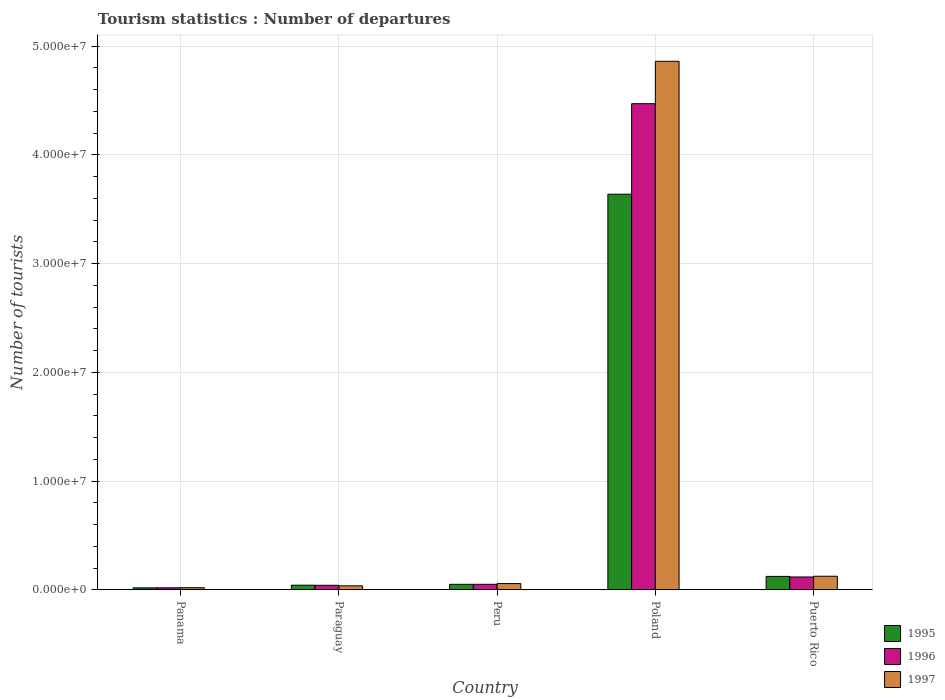How many different coloured bars are there?
Provide a succinct answer. 3. How many groups of bars are there?
Offer a very short reply. 5. How many bars are there on the 2nd tick from the right?
Give a very brief answer. 3. What is the label of the 5th group of bars from the left?
Provide a succinct answer. Puerto Rico. In how many cases, is the number of bars for a given country not equal to the number of legend labels?
Keep it short and to the point. 0. What is the number of tourist departures in 1995 in Panama?
Give a very brief answer. 1.85e+05. Across all countries, what is the maximum number of tourist departures in 1997?
Give a very brief answer. 4.86e+07. Across all countries, what is the minimum number of tourist departures in 1997?
Offer a very short reply. 1.94e+05. In which country was the number of tourist departures in 1997 minimum?
Provide a short and direct response. Panama. What is the total number of tourist departures in 1996 in the graph?
Provide a short and direct response. 4.70e+07. What is the difference between the number of tourist departures in 1995 in Panama and that in Poland?
Your answer should be very brief. -3.62e+07. What is the difference between the number of tourist departures in 1995 in Peru and the number of tourist departures in 1997 in Paraguay?
Your answer should be very brief. 1.39e+05. What is the average number of tourist departures in 1995 per country?
Your answer should be very brief. 7.75e+06. What is the difference between the number of tourist departures of/in 1995 and number of tourist departures of/in 1996 in Panama?
Your answer should be very brief. -3000. In how many countries, is the number of tourist departures in 1997 greater than 46000000?
Make the answer very short. 1. What is the ratio of the number of tourist departures in 1997 in Peru to that in Poland?
Offer a terse response. 0.01. What is the difference between the highest and the second highest number of tourist departures in 1997?
Provide a succinct answer. 4.80e+07. What is the difference between the highest and the lowest number of tourist departures in 1995?
Give a very brief answer. 3.62e+07. Is the sum of the number of tourist departures in 1996 in Panama and Puerto Rico greater than the maximum number of tourist departures in 1997 across all countries?
Give a very brief answer. No. What does the 1st bar from the right in Puerto Rico represents?
Provide a succinct answer. 1997. How many bars are there?
Offer a very short reply. 15. Are all the bars in the graph horizontal?
Provide a succinct answer. No. What is the difference between two consecutive major ticks on the Y-axis?
Provide a succinct answer. 1.00e+07. Are the values on the major ticks of Y-axis written in scientific E-notation?
Your answer should be very brief. Yes. How many legend labels are there?
Your answer should be compact. 3. How are the legend labels stacked?
Your answer should be compact. Vertical. What is the title of the graph?
Provide a succinct answer. Tourism statistics : Number of departures. Does "2013" appear as one of the legend labels in the graph?
Your response must be concise. No. What is the label or title of the X-axis?
Ensure brevity in your answer.  Country. What is the label or title of the Y-axis?
Offer a very short reply. Number of tourists. What is the Number of tourists in 1995 in Panama?
Your response must be concise. 1.85e+05. What is the Number of tourists of 1996 in Panama?
Ensure brevity in your answer.  1.88e+05. What is the Number of tourists in 1997 in Panama?
Ensure brevity in your answer.  1.94e+05. What is the Number of tourists in 1995 in Paraguay?
Your response must be concise. 4.27e+05. What is the Number of tourists of 1996 in Paraguay?
Your answer should be very brief. 4.18e+05. What is the Number of tourists of 1997 in Paraguay?
Make the answer very short. 3.69e+05. What is the Number of tourists of 1995 in Peru?
Your answer should be very brief. 5.08e+05. What is the Number of tourists of 1996 in Peru?
Provide a short and direct response. 5.10e+05. What is the Number of tourists of 1997 in Peru?
Make the answer very short. 5.77e+05. What is the Number of tourists of 1995 in Poland?
Provide a succinct answer. 3.64e+07. What is the Number of tourists of 1996 in Poland?
Provide a succinct answer. 4.47e+07. What is the Number of tourists in 1997 in Poland?
Your response must be concise. 4.86e+07. What is the Number of tourists of 1995 in Puerto Rico?
Your response must be concise. 1.24e+06. What is the Number of tourists in 1996 in Puerto Rico?
Give a very brief answer. 1.18e+06. What is the Number of tourists of 1997 in Puerto Rico?
Ensure brevity in your answer.  1.25e+06. Across all countries, what is the maximum Number of tourists in 1995?
Your answer should be very brief. 3.64e+07. Across all countries, what is the maximum Number of tourists of 1996?
Your response must be concise. 4.47e+07. Across all countries, what is the maximum Number of tourists in 1997?
Make the answer very short. 4.86e+07. Across all countries, what is the minimum Number of tourists in 1995?
Your answer should be compact. 1.85e+05. Across all countries, what is the minimum Number of tourists in 1996?
Make the answer very short. 1.88e+05. Across all countries, what is the minimum Number of tourists in 1997?
Give a very brief answer. 1.94e+05. What is the total Number of tourists in 1995 in the graph?
Your answer should be very brief. 3.87e+07. What is the total Number of tourists of 1996 in the graph?
Make the answer very short. 4.70e+07. What is the total Number of tourists in 1997 in the graph?
Your answer should be compact. 5.10e+07. What is the difference between the Number of tourists in 1995 in Panama and that in Paraguay?
Ensure brevity in your answer.  -2.42e+05. What is the difference between the Number of tourists of 1996 in Panama and that in Paraguay?
Your response must be concise. -2.30e+05. What is the difference between the Number of tourists in 1997 in Panama and that in Paraguay?
Keep it short and to the point. -1.75e+05. What is the difference between the Number of tourists of 1995 in Panama and that in Peru?
Provide a succinct answer. -3.23e+05. What is the difference between the Number of tourists in 1996 in Panama and that in Peru?
Offer a very short reply. -3.22e+05. What is the difference between the Number of tourists of 1997 in Panama and that in Peru?
Ensure brevity in your answer.  -3.83e+05. What is the difference between the Number of tourists of 1995 in Panama and that in Poland?
Your response must be concise. -3.62e+07. What is the difference between the Number of tourists of 1996 in Panama and that in Poland?
Give a very brief answer. -4.45e+07. What is the difference between the Number of tourists of 1997 in Panama and that in Poland?
Ensure brevity in your answer.  -4.84e+07. What is the difference between the Number of tourists in 1995 in Panama and that in Puerto Rico?
Offer a very short reply. -1.05e+06. What is the difference between the Number of tourists in 1996 in Panama and that in Puerto Rico?
Your answer should be compact. -9.96e+05. What is the difference between the Number of tourists in 1997 in Panama and that in Puerto Rico?
Ensure brevity in your answer.  -1.06e+06. What is the difference between the Number of tourists in 1995 in Paraguay and that in Peru?
Offer a very short reply. -8.10e+04. What is the difference between the Number of tourists of 1996 in Paraguay and that in Peru?
Your answer should be compact. -9.20e+04. What is the difference between the Number of tourists of 1997 in Paraguay and that in Peru?
Make the answer very short. -2.08e+05. What is the difference between the Number of tourists in 1995 in Paraguay and that in Poland?
Ensure brevity in your answer.  -3.60e+07. What is the difference between the Number of tourists in 1996 in Paraguay and that in Poland?
Your answer should be very brief. -4.43e+07. What is the difference between the Number of tourists of 1997 in Paraguay and that in Poland?
Keep it short and to the point. -4.82e+07. What is the difference between the Number of tourists in 1995 in Paraguay and that in Puerto Rico?
Keep it short and to the point. -8.10e+05. What is the difference between the Number of tourists of 1996 in Paraguay and that in Puerto Rico?
Your answer should be very brief. -7.66e+05. What is the difference between the Number of tourists in 1997 in Paraguay and that in Puerto Rico?
Provide a succinct answer. -8.82e+05. What is the difference between the Number of tourists in 1995 in Peru and that in Poland?
Your answer should be compact. -3.59e+07. What is the difference between the Number of tourists in 1996 in Peru and that in Poland?
Give a very brief answer. -4.42e+07. What is the difference between the Number of tourists of 1997 in Peru and that in Poland?
Your answer should be compact. -4.80e+07. What is the difference between the Number of tourists of 1995 in Peru and that in Puerto Rico?
Provide a short and direct response. -7.29e+05. What is the difference between the Number of tourists of 1996 in Peru and that in Puerto Rico?
Your answer should be very brief. -6.74e+05. What is the difference between the Number of tourists of 1997 in Peru and that in Puerto Rico?
Offer a very short reply. -6.74e+05. What is the difference between the Number of tourists in 1995 in Poland and that in Puerto Rico?
Your answer should be very brief. 3.52e+07. What is the difference between the Number of tourists in 1996 in Poland and that in Puerto Rico?
Your answer should be very brief. 4.35e+07. What is the difference between the Number of tourists of 1997 in Poland and that in Puerto Rico?
Make the answer very short. 4.74e+07. What is the difference between the Number of tourists of 1995 in Panama and the Number of tourists of 1996 in Paraguay?
Offer a terse response. -2.33e+05. What is the difference between the Number of tourists of 1995 in Panama and the Number of tourists of 1997 in Paraguay?
Provide a short and direct response. -1.84e+05. What is the difference between the Number of tourists in 1996 in Panama and the Number of tourists in 1997 in Paraguay?
Your response must be concise. -1.81e+05. What is the difference between the Number of tourists of 1995 in Panama and the Number of tourists of 1996 in Peru?
Give a very brief answer. -3.25e+05. What is the difference between the Number of tourists in 1995 in Panama and the Number of tourists in 1997 in Peru?
Provide a short and direct response. -3.92e+05. What is the difference between the Number of tourists of 1996 in Panama and the Number of tourists of 1997 in Peru?
Provide a succinct answer. -3.89e+05. What is the difference between the Number of tourists of 1995 in Panama and the Number of tourists of 1996 in Poland?
Give a very brief answer. -4.45e+07. What is the difference between the Number of tourists in 1995 in Panama and the Number of tourists in 1997 in Poland?
Provide a succinct answer. -4.84e+07. What is the difference between the Number of tourists in 1996 in Panama and the Number of tourists in 1997 in Poland?
Offer a terse response. -4.84e+07. What is the difference between the Number of tourists of 1995 in Panama and the Number of tourists of 1996 in Puerto Rico?
Provide a short and direct response. -9.99e+05. What is the difference between the Number of tourists in 1995 in Panama and the Number of tourists in 1997 in Puerto Rico?
Provide a succinct answer. -1.07e+06. What is the difference between the Number of tourists of 1996 in Panama and the Number of tourists of 1997 in Puerto Rico?
Your response must be concise. -1.06e+06. What is the difference between the Number of tourists in 1995 in Paraguay and the Number of tourists in 1996 in Peru?
Your answer should be compact. -8.30e+04. What is the difference between the Number of tourists of 1996 in Paraguay and the Number of tourists of 1997 in Peru?
Give a very brief answer. -1.59e+05. What is the difference between the Number of tourists in 1995 in Paraguay and the Number of tourists in 1996 in Poland?
Your response must be concise. -4.43e+07. What is the difference between the Number of tourists in 1995 in Paraguay and the Number of tourists in 1997 in Poland?
Make the answer very short. -4.82e+07. What is the difference between the Number of tourists of 1996 in Paraguay and the Number of tourists of 1997 in Poland?
Offer a terse response. -4.82e+07. What is the difference between the Number of tourists of 1995 in Paraguay and the Number of tourists of 1996 in Puerto Rico?
Your response must be concise. -7.57e+05. What is the difference between the Number of tourists of 1995 in Paraguay and the Number of tourists of 1997 in Puerto Rico?
Ensure brevity in your answer.  -8.24e+05. What is the difference between the Number of tourists in 1996 in Paraguay and the Number of tourists in 1997 in Puerto Rico?
Keep it short and to the point. -8.33e+05. What is the difference between the Number of tourists in 1995 in Peru and the Number of tourists in 1996 in Poland?
Keep it short and to the point. -4.42e+07. What is the difference between the Number of tourists in 1995 in Peru and the Number of tourists in 1997 in Poland?
Give a very brief answer. -4.81e+07. What is the difference between the Number of tourists of 1996 in Peru and the Number of tourists of 1997 in Poland?
Offer a very short reply. -4.81e+07. What is the difference between the Number of tourists in 1995 in Peru and the Number of tourists in 1996 in Puerto Rico?
Your answer should be compact. -6.76e+05. What is the difference between the Number of tourists in 1995 in Peru and the Number of tourists in 1997 in Puerto Rico?
Your response must be concise. -7.43e+05. What is the difference between the Number of tourists in 1996 in Peru and the Number of tourists in 1997 in Puerto Rico?
Your answer should be very brief. -7.41e+05. What is the difference between the Number of tourists of 1995 in Poland and the Number of tourists of 1996 in Puerto Rico?
Your answer should be very brief. 3.52e+07. What is the difference between the Number of tourists in 1995 in Poland and the Number of tourists in 1997 in Puerto Rico?
Keep it short and to the point. 3.51e+07. What is the difference between the Number of tourists of 1996 in Poland and the Number of tourists of 1997 in Puerto Rico?
Offer a very short reply. 4.35e+07. What is the average Number of tourists in 1995 per country?
Offer a very short reply. 7.75e+06. What is the average Number of tourists of 1996 per country?
Give a very brief answer. 9.40e+06. What is the average Number of tourists in 1997 per country?
Provide a succinct answer. 1.02e+07. What is the difference between the Number of tourists in 1995 and Number of tourists in 1996 in Panama?
Ensure brevity in your answer.  -3000. What is the difference between the Number of tourists of 1995 and Number of tourists of 1997 in Panama?
Your answer should be very brief. -9000. What is the difference between the Number of tourists of 1996 and Number of tourists of 1997 in Panama?
Offer a terse response. -6000. What is the difference between the Number of tourists of 1995 and Number of tourists of 1996 in Paraguay?
Keep it short and to the point. 9000. What is the difference between the Number of tourists of 1995 and Number of tourists of 1997 in Paraguay?
Your answer should be very brief. 5.80e+04. What is the difference between the Number of tourists of 1996 and Number of tourists of 1997 in Paraguay?
Provide a short and direct response. 4.90e+04. What is the difference between the Number of tourists of 1995 and Number of tourists of 1996 in Peru?
Provide a short and direct response. -2000. What is the difference between the Number of tourists of 1995 and Number of tourists of 1997 in Peru?
Offer a terse response. -6.90e+04. What is the difference between the Number of tourists in 1996 and Number of tourists in 1997 in Peru?
Give a very brief answer. -6.70e+04. What is the difference between the Number of tourists of 1995 and Number of tourists of 1996 in Poland?
Ensure brevity in your answer.  -8.33e+06. What is the difference between the Number of tourists of 1995 and Number of tourists of 1997 in Poland?
Ensure brevity in your answer.  -1.22e+07. What is the difference between the Number of tourists in 1996 and Number of tourists in 1997 in Poland?
Provide a short and direct response. -3.90e+06. What is the difference between the Number of tourists of 1995 and Number of tourists of 1996 in Puerto Rico?
Give a very brief answer. 5.30e+04. What is the difference between the Number of tourists in 1995 and Number of tourists in 1997 in Puerto Rico?
Your answer should be very brief. -1.40e+04. What is the difference between the Number of tourists in 1996 and Number of tourists in 1997 in Puerto Rico?
Make the answer very short. -6.70e+04. What is the ratio of the Number of tourists in 1995 in Panama to that in Paraguay?
Offer a terse response. 0.43. What is the ratio of the Number of tourists of 1996 in Panama to that in Paraguay?
Ensure brevity in your answer.  0.45. What is the ratio of the Number of tourists of 1997 in Panama to that in Paraguay?
Provide a succinct answer. 0.53. What is the ratio of the Number of tourists of 1995 in Panama to that in Peru?
Give a very brief answer. 0.36. What is the ratio of the Number of tourists of 1996 in Panama to that in Peru?
Ensure brevity in your answer.  0.37. What is the ratio of the Number of tourists of 1997 in Panama to that in Peru?
Provide a short and direct response. 0.34. What is the ratio of the Number of tourists of 1995 in Panama to that in Poland?
Ensure brevity in your answer.  0.01. What is the ratio of the Number of tourists of 1996 in Panama to that in Poland?
Give a very brief answer. 0. What is the ratio of the Number of tourists of 1997 in Panama to that in Poland?
Your answer should be compact. 0. What is the ratio of the Number of tourists of 1995 in Panama to that in Puerto Rico?
Ensure brevity in your answer.  0.15. What is the ratio of the Number of tourists in 1996 in Panama to that in Puerto Rico?
Your answer should be very brief. 0.16. What is the ratio of the Number of tourists in 1997 in Panama to that in Puerto Rico?
Provide a succinct answer. 0.16. What is the ratio of the Number of tourists of 1995 in Paraguay to that in Peru?
Offer a very short reply. 0.84. What is the ratio of the Number of tourists in 1996 in Paraguay to that in Peru?
Offer a very short reply. 0.82. What is the ratio of the Number of tourists in 1997 in Paraguay to that in Peru?
Keep it short and to the point. 0.64. What is the ratio of the Number of tourists of 1995 in Paraguay to that in Poland?
Give a very brief answer. 0.01. What is the ratio of the Number of tourists of 1996 in Paraguay to that in Poland?
Your response must be concise. 0.01. What is the ratio of the Number of tourists in 1997 in Paraguay to that in Poland?
Provide a succinct answer. 0.01. What is the ratio of the Number of tourists in 1995 in Paraguay to that in Puerto Rico?
Offer a very short reply. 0.35. What is the ratio of the Number of tourists in 1996 in Paraguay to that in Puerto Rico?
Your answer should be very brief. 0.35. What is the ratio of the Number of tourists of 1997 in Paraguay to that in Puerto Rico?
Your response must be concise. 0.29. What is the ratio of the Number of tourists of 1995 in Peru to that in Poland?
Keep it short and to the point. 0.01. What is the ratio of the Number of tourists of 1996 in Peru to that in Poland?
Ensure brevity in your answer.  0.01. What is the ratio of the Number of tourists of 1997 in Peru to that in Poland?
Provide a short and direct response. 0.01. What is the ratio of the Number of tourists of 1995 in Peru to that in Puerto Rico?
Your answer should be very brief. 0.41. What is the ratio of the Number of tourists of 1996 in Peru to that in Puerto Rico?
Make the answer very short. 0.43. What is the ratio of the Number of tourists in 1997 in Peru to that in Puerto Rico?
Keep it short and to the point. 0.46. What is the ratio of the Number of tourists of 1995 in Poland to that in Puerto Rico?
Your answer should be compact. 29.42. What is the ratio of the Number of tourists of 1996 in Poland to that in Puerto Rico?
Keep it short and to the point. 37.76. What is the ratio of the Number of tourists of 1997 in Poland to that in Puerto Rico?
Provide a succinct answer. 38.86. What is the difference between the highest and the second highest Number of tourists in 1995?
Make the answer very short. 3.52e+07. What is the difference between the highest and the second highest Number of tourists in 1996?
Make the answer very short. 4.35e+07. What is the difference between the highest and the second highest Number of tourists in 1997?
Your response must be concise. 4.74e+07. What is the difference between the highest and the lowest Number of tourists of 1995?
Offer a terse response. 3.62e+07. What is the difference between the highest and the lowest Number of tourists in 1996?
Your answer should be compact. 4.45e+07. What is the difference between the highest and the lowest Number of tourists in 1997?
Your answer should be very brief. 4.84e+07. 